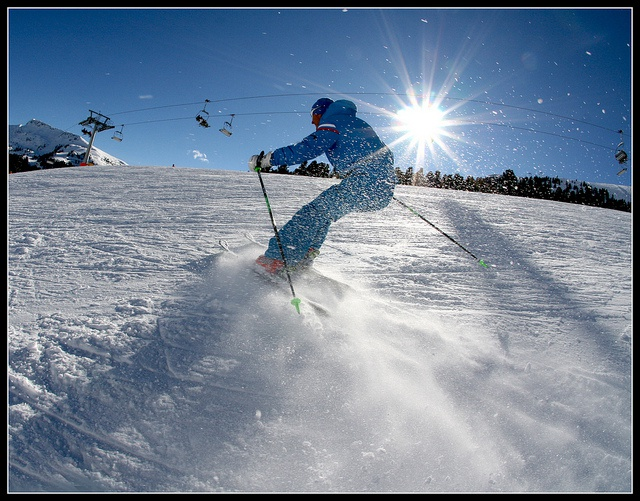Describe the objects in this image and their specific colors. I can see people in black, navy, blue, gray, and darkgray tones, skis in black, lightgray, darkgray, and gray tones, chair in black, blue, and gray tones, chair in black and gray tones, and chair in black and gray tones in this image. 